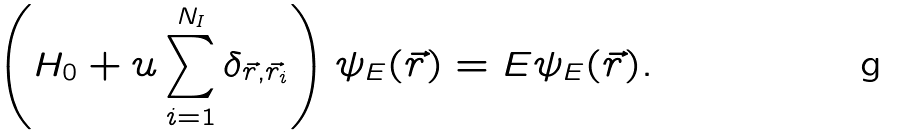Convert formula to latex. <formula><loc_0><loc_0><loc_500><loc_500>\left ( H _ { 0 } + u \sum ^ { N _ { I } } _ { i = 1 } \delta _ { \vec { r } , \vec { r } _ { i } } \right ) \psi _ { E } ( { \vec { r } } ) = E \psi _ { E } ( { \vec { r } } ) .</formula> 